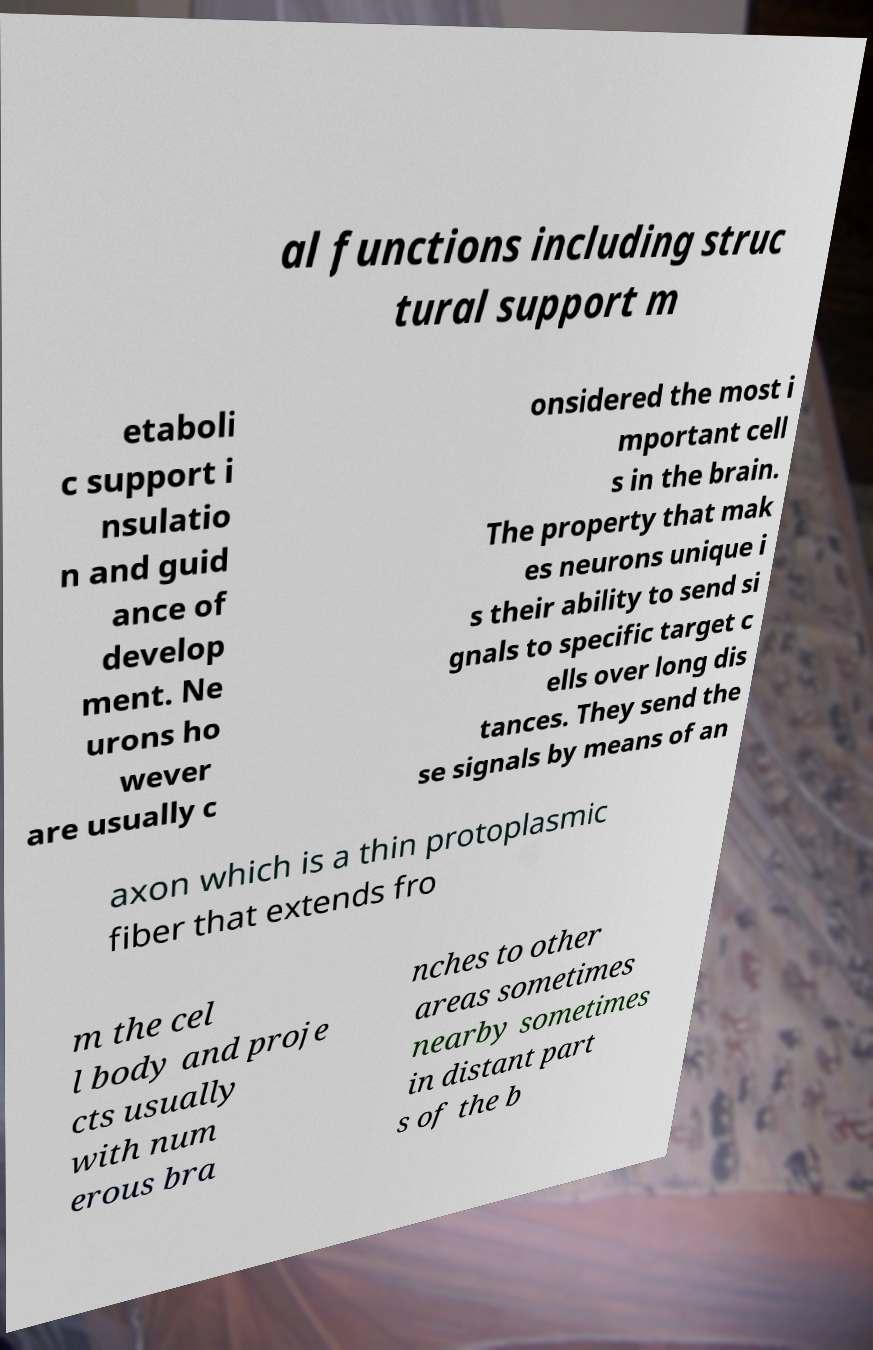I need the written content from this picture converted into text. Can you do that? al functions including struc tural support m etaboli c support i nsulatio n and guid ance of develop ment. Ne urons ho wever are usually c onsidered the most i mportant cell s in the brain. The property that mak es neurons unique i s their ability to send si gnals to specific target c ells over long dis tances. They send the se signals by means of an axon which is a thin protoplasmic fiber that extends fro m the cel l body and proje cts usually with num erous bra nches to other areas sometimes nearby sometimes in distant part s of the b 